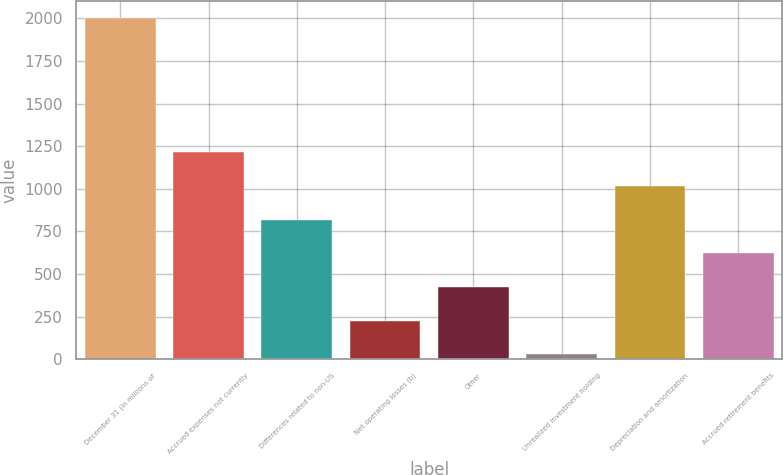Convert chart to OTSL. <chart><loc_0><loc_0><loc_500><loc_500><bar_chart><fcel>December 31 (In millions of<fcel>Accrued expenses not currently<fcel>Differences related to non-US<fcel>Net operating losses (b)<fcel>Other<fcel>Unrealized investment holding<fcel>Depreciation and amortization<fcel>Accrued retirement benefits<nl><fcel>2005<fcel>1214.6<fcel>819.4<fcel>226.6<fcel>424.2<fcel>29<fcel>1017<fcel>621.8<nl></chart> 